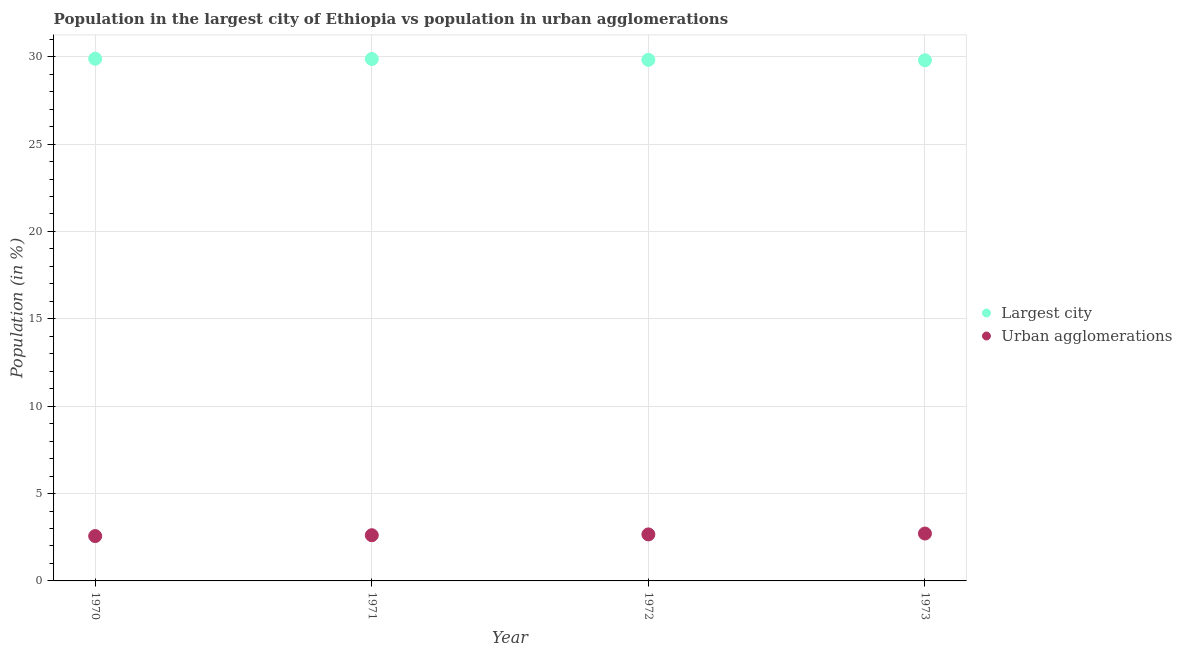What is the population in urban agglomerations in 1972?
Give a very brief answer. 2.66. Across all years, what is the maximum population in the largest city?
Provide a short and direct response. 29.88. Across all years, what is the minimum population in urban agglomerations?
Provide a succinct answer. 2.57. In which year was the population in urban agglomerations minimum?
Your answer should be very brief. 1970. What is the total population in urban agglomerations in the graph?
Keep it short and to the point. 10.56. What is the difference between the population in urban agglomerations in 1970 and that in 1972?
Make the answer very short. -0.1. What is the difference between the population in the largest city in 1973 and the population in urban agglomerations in 1970?
Provide a short and direct response. 27.23. What is the average population in the largest city per year?
Ensure brevity in your answer.  29.84. In the year 1972, what is the difference between the population in urban agglomerations and population in the largest city?
Offer a terse response. -27.16. In how many years, is the population in urban agglomerations greater than 24 %?
Your answer should be very brief. 0. What is the ratio of the population in the largest city in 1971 to that in 1973?
Give a very brief answer. 1. Is the population in the largest city in 1971 less than that in 1972?
Offer a terse response. No. What is the difference between the highest and the second highest population in the largest city?
Your response must be concise. 0.01. What is the difference between the highest and the lowest population in the largest city?
Keep it short and to the point. 0.09. In how many years, is the population in the largest city greater than the average population in the largest city taken over all years?
Provide a succinct answer. 2. Is the population in the largest city strictly less than the population in urban agglomerations over the years?
Ensure brevity in your answer.  No. How many dotlines are there?
Provide a short and direct response. 2. What is the difference between two consecutive major ticks on the Y-axis?
Offer a very short reply. 5. Where does the legend appear in the graph?
Provide a short and direct response. Center right. How are the legend labels stacked?
Your answer should be compact. Vertical. What is the title of the graph?
Provide a short and direct response. Population in the largest city of Ethiopia vs population in urban agglomerations. What is the Population (in %) in Largest city in 1970?
Provide a short and direct response. 29.88. What is the Population (in %) in Urban agglomerations in 1970?
Provide a short and direct response. 2.57. What is the Population (in %) of Largest city in 1971?
Your response must be concise. 29.87. What is the Population (in %) of Urban agglomerations in 1971?
Offer a terse response. 2.62. What is the Population (in %) in Largest city in 1972?
Your response must be concise. 29.82. What is the Population (in %) in Urban agglomerations in 1972?
Give a very brief answer. 2.66. What is the Population (in %) of Largest city in 1973?
Provide a succinct answer. 29.79. What is the Population (in %) of Urban agglomerations in 1973?
Your response must be concise. 2.71. Across all years, what is the maximum Population (in %) of Largest city?
Offer a very short reply. 29.88. Across all years, what is the maximum Population (in %) in Urban agglomerations?
Offer a very short reply. 2.71. Across all years, what is the minimum Population (in %) of Largest city?
Your answer should be compact. 29.79. Across all years, what is the minimum Population (in %) in Urban agglomerations?
Offer a very short reply. 2.57. What is the total Population (in %) in Largest city in the graph?
Offer a terse response. 119.37. What is the total Population (in %) of Urban agglomerations in the graph?
Your response must be concise. 10.56. What is the difference between the Population (in %) of Largest city in 1970 and that in 1971?
Offer a very short reply. 0.01. What is the difference between the Population (in %) in Urban agglomerations in 1970 and that in 1971?
Offer a very short reply. -0.05. What is the difference between the Population (in %) of Largest city in 1970 and that in 1972?
Keep it short and to the point. 0.06. What is the difference between the Population (in %) in Urban agglomerations in 1970 and that in 1972?
Ensure brevity in your answer.  -0.1. What is the difference between the Population (in %) in Largest city in 1970 and that in 1973?
Provide a short and direct response. 0.09. What is the difference between the Population (in %) in Urban agglomerations in 1970 and that in 1973?
Offer a terse response. -0.15. What is the difference between the Population (in %) of Largest city in 1971 and that in 1972?
Make the answer very short. 0.05. What is the difference between the Population (in %) of Urban agglomerations in 1971 and that in 1972?
Keep it short and to the point. -0.05. What is the difference between the Population (in %) in Largest city in 1971 and that in 1973?
Give a very brief answer. 0.07. What is the difference between the Population (in %) of Urban agglomerations in 1971 and that in 1973?
Make the answer very short. -0.1. What is the difference between the Population (in %) in Largest city in 1972 and that in 1973?
Provide a short and direct response. 0.03. What is the difference between the Population (in %) of Urban agglomerations in 1972 and that in 1973?
Your answer should be compact. -0.05. What is the difference between the Population (in %) in Largest city in 1970 and the Population (in %) in Urban agglomerations in 1971?
Offer a terse response. 27.27. What is the difference between the Population (in %) in Largest city in 1970 and the Population (in %) in Urban agglomerations in 1972?
Make the answer very short. 27.22. What is the difference between the Population (in %) of Largest city in 1970 and the Population (in %) of Urban agglomerations in 1973?
Offer a terse response. 27.17. What is the difference between the Population (in %) of Largest city in 1971 and the Population (in %) of Urban agglomerations in 1972?
Ensure brevity in your answer.  27.21. What is the difference between the Population (in %) of Largest city in 1971 and the Population (in %) of Urban agglomerations in 1973?
Your response must be concise. 27.16. What is the difference between the Population (in %) of Largest city in 1972 and the Population (in %) of Urban agglomerations in 1973?
Your answer should be compact. 27.11. What is the average Population (in %) in Largest city per year?
Provide a short and direct response. 29.84. What is the average Population (in %) in Urban agglomerations per year?
Offer a terse response. 2.64. In the year 1970, what is the difference between the Population (in %) of Largest city and Population (in %) of Urban agglomerations?
Give a very brief answer. 27.32. In the year 1971, what is the difference between the Population (in %) in Largest city and Population (in %) in Urban agglomerations?
Your answer should be compact. 27.25. In the year 1972, what is the difference between the Population (in %) in Largest city and Population (in %) in Urban agglomerations?
Your response must be concise. 27.16. In the year 1973, what is the difference between the Population (in %) of Largest city and Population (in %) of Urban agglomerations?
Offer a very short reply. 27.08. What is the ratio of the Population (in %) in Largest city in 1970 to that in 1971?
Your response must be concise. 1. What is the ratio of the Population (in %) in Urban agglomerations in 1970 to that in 1971?
Offer a very short reply. 0.98. What is the ratio of the Population (in %) of Largest city in 1970 to that in 1972?
Your response must be concise. 1. What is the ratio of the Population (in %) in Urban agglomerations in 1970 to that in 1972?
Offer a very short reply. 0.96. What is the ratio of the Population (in %) of Urban agglomerations in 1970 to that in 1973?
Give a very brief answer. 0.95. What is the ratio of the Population (in %) of Largest city in 1971 to that in 1972?
Keep it short and to the point. 1. What is the ratio of the Population (in %) of Urban agglomerations in 1971 to that in 1972?
Ensure brevity in your answer.  0.98. What is the ratio of the Population (in %) in Largest city in 1971 to that in 1973?
Keep it short and to the point. 1. What is the ratio of the Population (in %) in Urban agglomerations in 1971 to that in 1973?
Keep it short and to the point. 0.96. What is the ratio of the Population (in %) of Urban agglomerations in 1972 to that in 1973?
Offer a very short reply. 0.98. What is the difference between the highest and the second highest Population (in %) in Largest city?
Ensure brevity in your answer.  0.01. What is the difference between the highest and the second highest Population (in %) in Urban agglomerations?
Your answer should be very brief. 0.05. What is the difference between the highest and the lowest Population (in %) of Largest city?
Offer a very short reply. 0.09. What is the difference between the highest and the lowest Population (in %) in Urban agglomerations?
Ensure brevity in your answer.  0.15. 